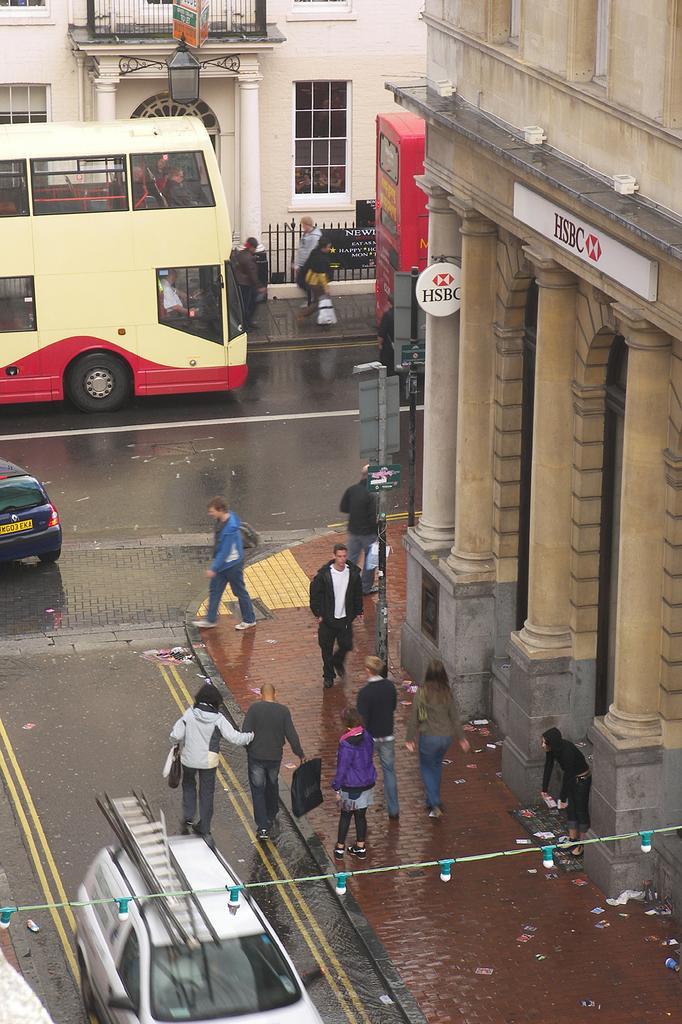How would you summarize this image in a sentence or two? In this picture I can see few buildings and a double decker bus and few cars on the road and few people walking on the sidewalk and a pole light and a board to the pole on the sidewalk and I can see boards with some text on the buildings and few serial bulbs. 